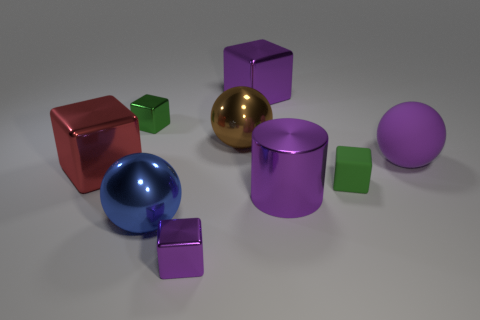How many green matte cubes are in front of the green rubber object? There are two green matte cubes situated in front of the green cylindrical rubber object. 